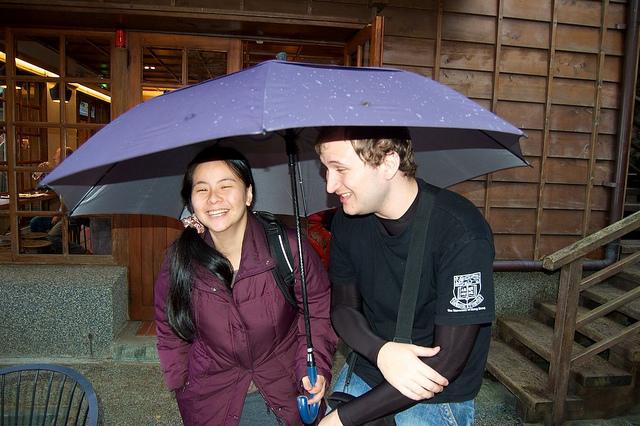How many umbrellas are there?
Short answer required. 1. What are the steps made out of?
Short answer required. Wood. How do we know it's raining?
Give a very brief answer. Umbrella. What color is the umbrella?
Keep it brief. Blue. Are the people sharing the umbrella?
Write a very short answer. Yes. 